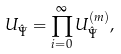Convert formula to latex. <formula><loc_0><loc_0><loc_500><loc_500>U _ { \hat { \Psi } } = \prod _ { i = 0 } ^ { \infty } U _ { \hat { \Psi } } ^ { ( m ) } ,</formula> 